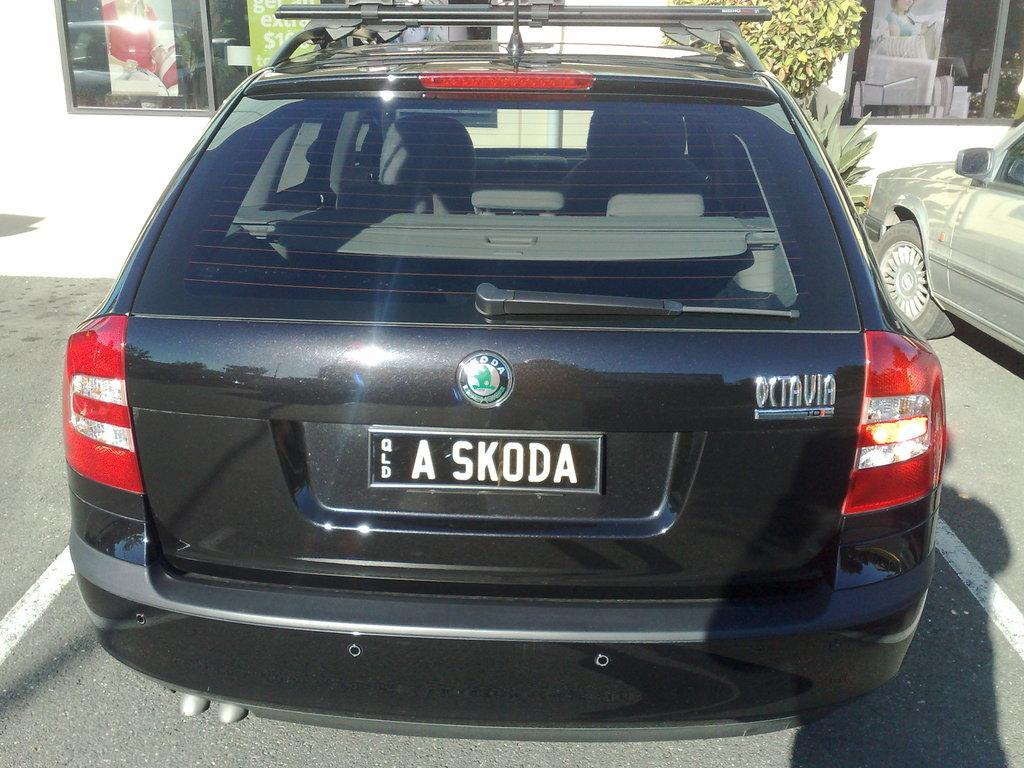Provide a one-sentence caption for the provided image. BMW Station wagon from the back side view with number plate A Skoda. 